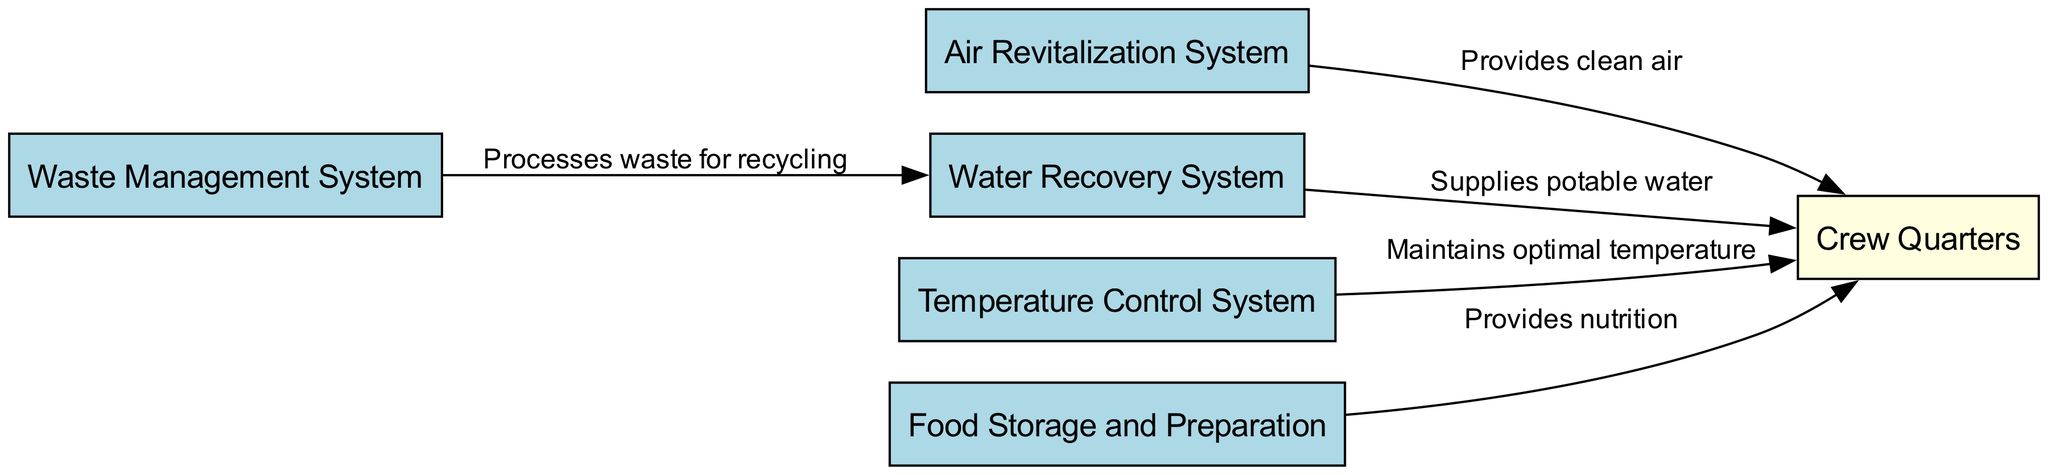What is the total number of nodes in the diagram? The diagram lists six distinct elements that are critical for the life support systems on the spacecraft: Air Revitalization System, Water Recovery System, Waste Management System, Temperature Control System, Food Storage and Preparation, and Crew Quarters. By counting these nodes, we find there are six in total.
Answer: 6 Which system provides clean air? Referring to the diagram, the Air Revitalization System is linked directly to the Crew Quarters and is labeled as providing clean air. Therefore, this system is responsible for ensuring proper air quality for the crew.
Answer: Air Revitalization System What does the Waste Management System do? The Waste Management System is illustrated as processing waste for recycling, which connects it to the Water Recovery System. This means its role is focused on managing waste in a way that allows for the recovery and reuse of resources.
Answer: Processes waste for recycling How does the Temperature Control System affect the Crew Quarters? The diagram indicates that the Temperature Control System maintains optimal temperature conditions within the Crew Quarters. This direct connection shows that controlling the temperature is vital for the comfort and safety of the crew.
Answer: Maintains optimal temperature Which system supplies potable water? The Water Recovery System is shown connected to the Crew Quarters with a labeled edge stating it supplies potable water. This system ensures that the crew has access to clean and safe drinking water during their mission.
Answer: Supplies potable water Which systems directly connect to the Crew Quarters? The diagram shows that five systems are directly linked to the Crew Quarters, namely: Air Revitalization System, Water Recovery System, Temperature Control System, Food Storage and Preparation, and Waste Management System, indicating the multiple sources ensuring crew well-being.
Answer: Five systems What role does the Food Storage and Preparation system play in relation to the Crew Quarters? The diagram illustrates that the Food Storage and Preparation system is responsible for providing nutrition to the Crew Quarters. This highlights the necessity of food supplies for long-duration missions in space.
Answer: Provides nutrition What is the relationship between the Waste Management System and the Water Recovery System? According to the diagram, the Waste Management System processes waste for recycling, which is then connected to the Water Recovery System. This indicates that waste management is integral to water recovery processes onboard the spacecraft.
Answer: Processes waste for recycling 